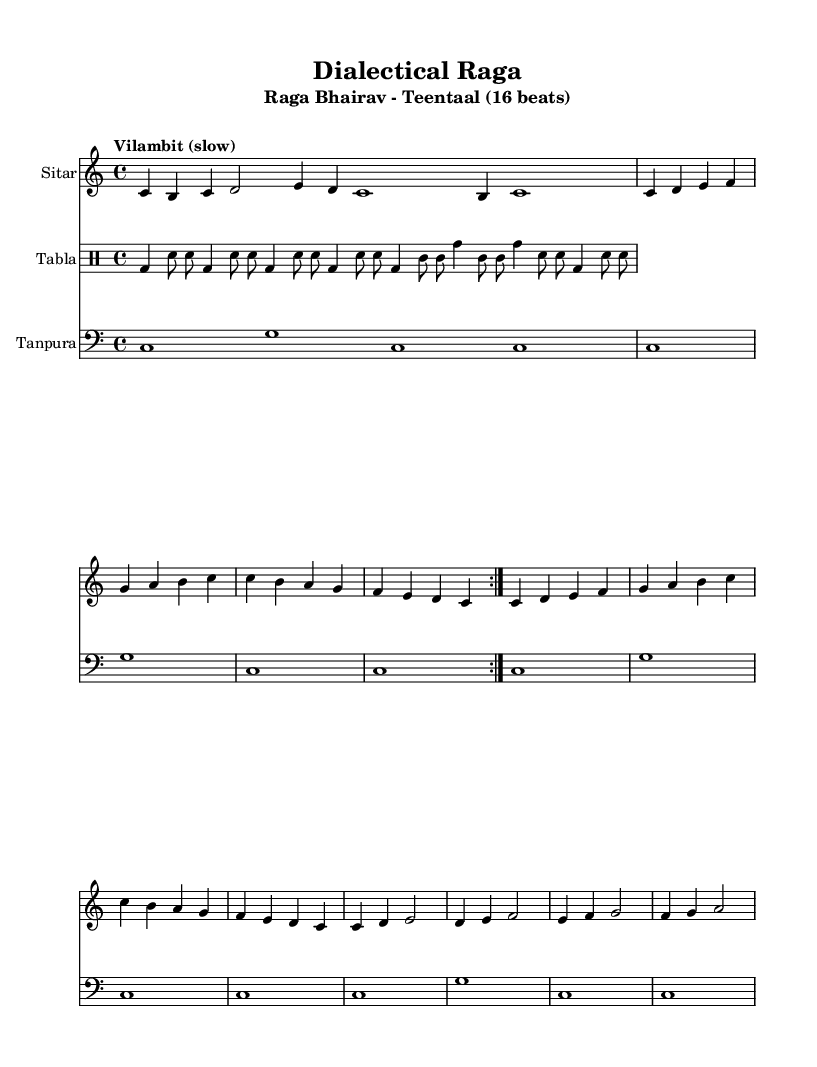What is the key signature of this music? The key signature is C major, which is indicated by the absence of any sharps or flats in the key signature section of the sheet music.
Answer: C major What is the time signature of the piece? The time signature is indicated at the beginning of the piece, and it shows that there are 4 beats in each measure, meaning it is in 4/4 time.
Answer: 4/4 What is the tempo marking for this composition? The tempo marking is "Vilambit (slow)," which indicates that the piece should be played slowly, providing a reflective and contemplative feel suitable for the raga.
Answer: Vilambit (slow) How many beats does Teentaal have? Teentaal is a traditional Tala in Indian classical music, and it consists of a total of 16 beats. This can be inferred from the number of subdivisions in the tabla part, which confirms the rhythm structure.
Answer: 16 beats What sections are present in this piece? The sections are Alap, Jor, and Jhala, which are distinct parts of Indian classical music that contribute to the overall structure and progression of the raga performance.
Answer: Alap, Jor, Jhala What instrument plays the melody? The melody is played on the Sitar, which is indicated by the instrument name at the beginning of the staff in the sheet music.
Answer: Sitar 